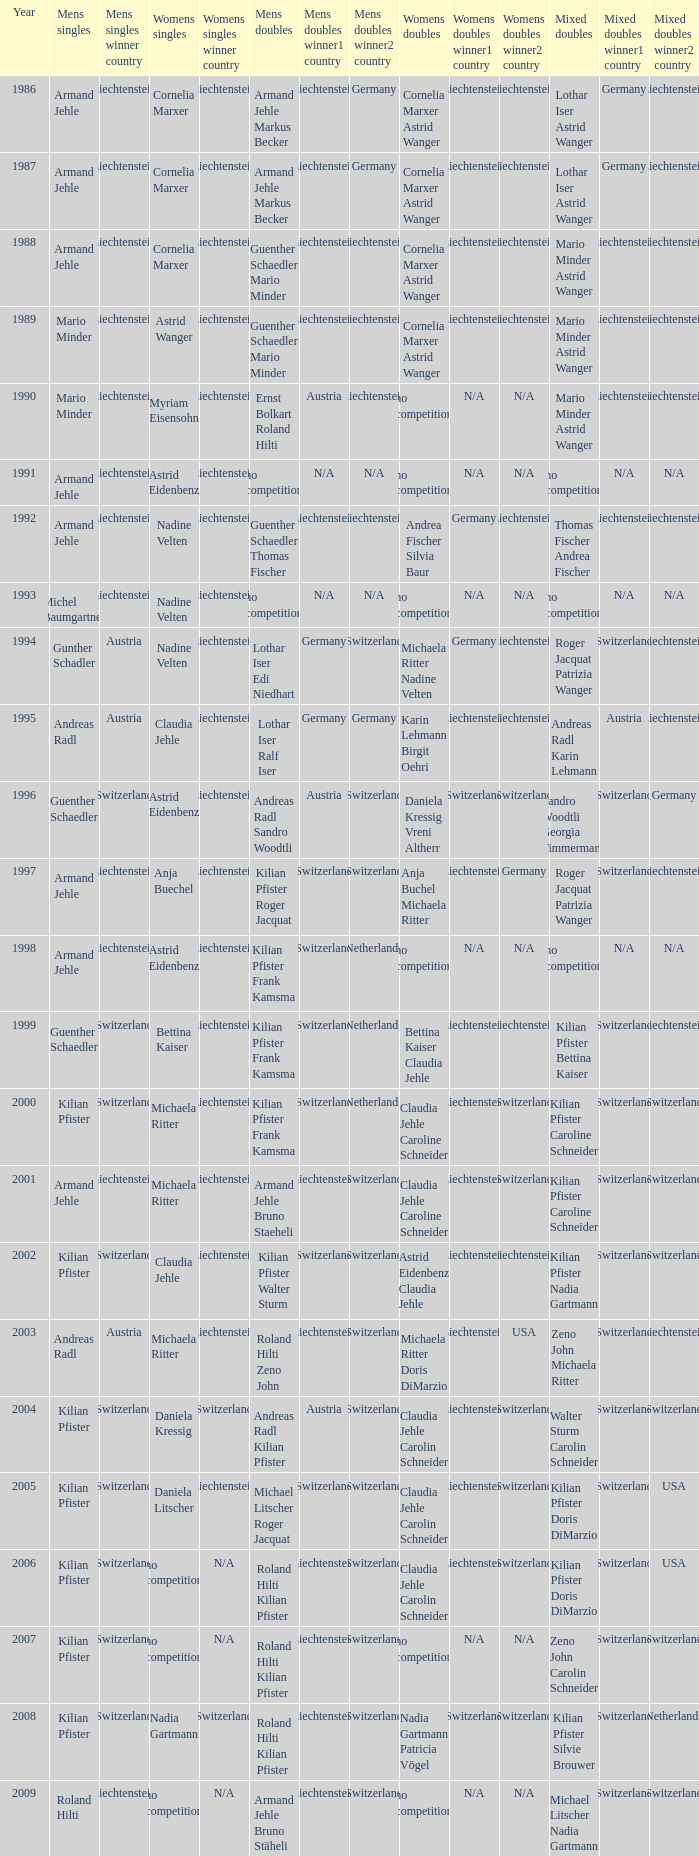Help me parse the entirety of this table. {'header': ['Year', 'Mens singles', 'Mens singles winner country', 'Womens singles', 'Womens singles winner country', 'Mens doubles', 'Mens doubles winner1 country', 'Mens doubles winner2 country', 'Womens doubles', 'Womens doubles winner1 country', 'Womens doubles winner2 country', 'Mixed doubles', 'Mixed doubles winner1 country', 'Mixed doubles winner2 country'], 'rows': [['1986', 'Armand Jehle', 'Liechtenstein', 'Cornelia Marxer', 'Liechtenstein', 'Armand Jehle Markus Becker', 'Liechtenstein', 'Germany', 'Cornelia Marxer Astrid Wanger', 'Liechtenstein', 'Liechtenstein', 'Lothar Iser Astrid Wanger', 'Germany', 'Liechtenstein'], ['1987', 'Armand Jehle', 'Liechtenstein', 'Cornelia Marxer', 'Liechtenstein', 'Armand Jehle Markus Becker', 'Liechtenstein', 'Germany', 'Cornelia Marxer Astrid Wanger', 'Liechtenstein', 'Liechtenstein', 'Lothar Iser Astrid Wanger', 'Germany', 'Liechtenstein'], ['1988', 'Armand Jehle', 'Liechtenstein', 'Cornelia Marxer', 'Liechtenstein', 'Guenther Schaedler Mario Minder', 'Liechtenstein', 'Liechtenstein', 'Cornelia Marxer Astrid Wanger', 'Liechtenstein', 'Liechtenstein', 'Mario Minder Astrid Wanger', 'Liechtenstein', 'Liechtenstein'], ['1989', 'Mario Minder', 'Liechtenstein', 'Astrid Wanger', 'Liechtenstein', 'Guenther Schaedler Mario Minder', 'Liechtenstein', 'Liechtenstein', 'Cornelia Marxer Astrid Wanger', 'Liechtenstein', 'Liechtenstein', 'Mario Minder Astrid Wanger', 'Liechtenstein', 'Liechtenstein'], ['1990', 'Mario Minder', 'Liechtenstein', 'Myriam Eisensohn', 'Liechtenstein', 'Ernst Bolkart Roland Hilti', 'Austria', 'Liechtenstein', 'no competition', 'N/A', 'N/A', 'Mario Minder Astrid Wanger', 'Liechtenstein', 'Liechtenstein'], ['1991', 'Armand Jehle', 'Liechtenstein', 'Astrid Eidenbenz', 'Liechtenstein', 'no competition', 'N/A', 'N/A', 'no competition', 'N/A', 'N/A', 'no competition', 'N/A', 'N/A'], ['1992', 'Armand Jehle', 'Liechtenstein', 'Nadine Velten', 'Liechtenstein', 'Guenther Schaedler Thomas Fischer', 'Liechtenstein', 'Liechtenstein', 'Andrea Fischer Silvia Baur', 'Germany', 'Liechtenstein', 'Thomas Fischer Andrea Fischer', 'Liechtenstein', 'Liechtenstein'], ['1993', 'Michel Baumgartner', 'Liechtenstein', 'Nadine Velten', 'Liechtenstein', 'no competition', 'N/A', 'N/A', 'no competition', 'N/A', 'N/A', 'no competition', 'N/A', 'N/A'], ['1994', 'Gunther Schadler', 'Austria', 'Nadine Velten', 'Liechtenstein', 'Lothar Iser Edi Niedhart', 'Germany', 'Switzerland', 'Michaela Ritter Nadine Velten', 'Germany', 'Liechtenstein', 'Roger Jacquat Patrizia Wanger', 'Switzerland', 'Liechtenstein'], ['1995', 'Andreas Radl', 'Austria', 'Claudia Jehle', 'Liechtenstein', 'Lothar Iser Ralf Iser', 'Germany', 'Germany', 'Karin Lehmann Birgit Oehri', 'Liechtenstein', 'Liechtenstein', 'Andreas Radl Karin Lehmann', 'Austria', 'Liechtenstein'], ['1996', 'Guenther Schaedler', 'Switzerland', 'Astrid Eidenbenz', 'Liechtenstein', 'Andreas Radl Sandro Woodtli', 'Austria', 'Switzerland', 'Daniela Kressig Vreni Altherr', 'Switzerland', 'Switzerland', 'Sandro Woodtli Georgia Timmermann', 'Switzerland', 'Germany'], ['1997', 'Armand Jehle', 'Liechtenstein', 'Anja Buechel', 'Liechtenstein', 'Kilian Pfister Roger Jacquat', 'Switzerland', 'Switzerland', 'Anja Buchel Michaela Ritter', 'Liechtenstein', 'Germany', 'Roger Jacquat Patrizia Wanger', 'Switzerland', 'Liechtenstein'], ['1998', 'Armand Jehle', 'Liechtenstein', 'Astrid Eidenbenz', 'Liechtenstein', 'Kilian Pfister Frank Kamsma', 'Switzerland', 'Netherlands', 'no competition', 'N/A', 'N/A', 'no competition', 'N/A', 'N/A'], ['1999', 'Guenther Schaedler', 'Switzerland', 'Bettina Kaiser', 'Liechtenstein', 'Kilian Pfister Frank Kamsma', 'Switzerland', 'Netherlands', 'Bettina Kaiser Claudia Jehle', 'Liechtenstein', 'Liechtenstein', 'Kilian Pfister Bettina Kaiser', 'Switzerland', 'Liechtenstein'], ['2000', 'Kilian Pfister', 'Switzerland', 'Michaela Ritter', 'Liechtenstein', 'Kilian Pfister Frank Kamsma', 'Switzerland', 'Netherlands', 'Claudia Jehle Caroline Schneider', 'Liechtenstein', 'Switzerland', 'Kilian Pfister Caroline Schneider', 'Switzerland', 'Switzerland'], ['2001', 'Armand Jehle', 'Liechtenstein', 'Michaela Ritter', 'Liechtenstein', 'Armand Jehle Bruno Staeheli', 'Liechtenstein', 'Switzerland', 'Claudia Jehle Caroline Schneider', 'Liechtenstein', 'Switzerland', 'Kilian Pfister Caroline Schneider', 'Switzerland', 'Switzerland'], ['2002', 'Kilian Pfister', 'Switzerland', 'Claudia Jehle', 'Liechtenstein', 'Kilian Pfister Walter Sturm', 'Switzerland', 'Switzerland', 'Astrid Eidenbenz Claudia Jehle', 'Liechtenstein', 'Liechtenstein', 'Kilian Pfister Nadia Gartmann', 'Switzerland', 'Switzerland'], ['2003', 'Andreas Radl', 'Austria', 'Michaela Ritter', 'Liechtenstein', 'Roland Hilti Zeno John', 'Liechtenstein', 'Switzerland', 'Michaela Ritter Doris DiMarzio', 'Liechtenstein', 'USA', 'Zeno John Michaela Ritter', 'Switzerland', 'Liechtenstein'], ['2004', 'Kilian Pfister', 'Switzerland', 'Daniela Kressig', 'Switzerland', 'Andreas Radl Kilian Pfister', 'Austria', 'Switzerland', 'Claudia Jehle Carolin Schneider', 'Liechtenstein', 'Switzerland', 'Walter Sturm Carolin Schneider', 'Switzerland', 'Switzerland'], ['2005', 'Kilian Pfister', 'Switzerland', 'Daniela Litscher', 'Liechtenstein', 'Michael Litscher Roger Jacquat', 'Switzerland', 'Switzerland', 'Claudia Jehle Carolin Schneider', 'Liechtenstein', 'Switzerland', 'Kilian Pfister Doris DiMarzio', 'Switzerland', 'USA'], ['2006', 'Kilian Pfister', 'Switzerland', 'no competition', 'N/A', 'Roland Hilti Kilian Pfister', 'Liechtenstein', 'Switzerland', 'Claudia Jehle Carolin Schneider', 'Liechtenstein', 'Switzerland', 'Kilian Pfister Doris DiMarzio', 'Switzerland', 'USA'], ['2007', 'Kilian Pfister', 'Switzerland', 'no competition', 'N/A', 'Roland Hilti Kilian Pfister', 'Liechtenstein', 'Switzerland', 'no competition', 'N/A', 'N/A', 'Zeno John Carolin Schneider', 'Switzerland', 'Switzerland'], ['2008', 'Kilian Pfister', 'Switzerland', 'Nadia Gartmann', 'Switzerland', 'Roland Hilti Kilian Pfister', 'Liechtenstein', 'Switzerland', 'Nadia Gartmann Patricia Vögel', 'Switzerland', 'Switzerland', 'Kilian Pfister Silvie Brouwer', 'Switzerland', 'Netherlands'], ['2009', 'Roland Hilti', 'Liechtenstein', 'no competition', 'N/A', 'Armand Jehle Bruno Stäheli', 'Liechtenstein', 'Switzerland', 'no competition', 'N/A', 'N/A', 'Michael Litscher Nadia Gartmann', 'Switzerland', 'Switzerland']]} In 2004, where the womens singles is daniela kressig who is the mens singles Kilian Pfister. 